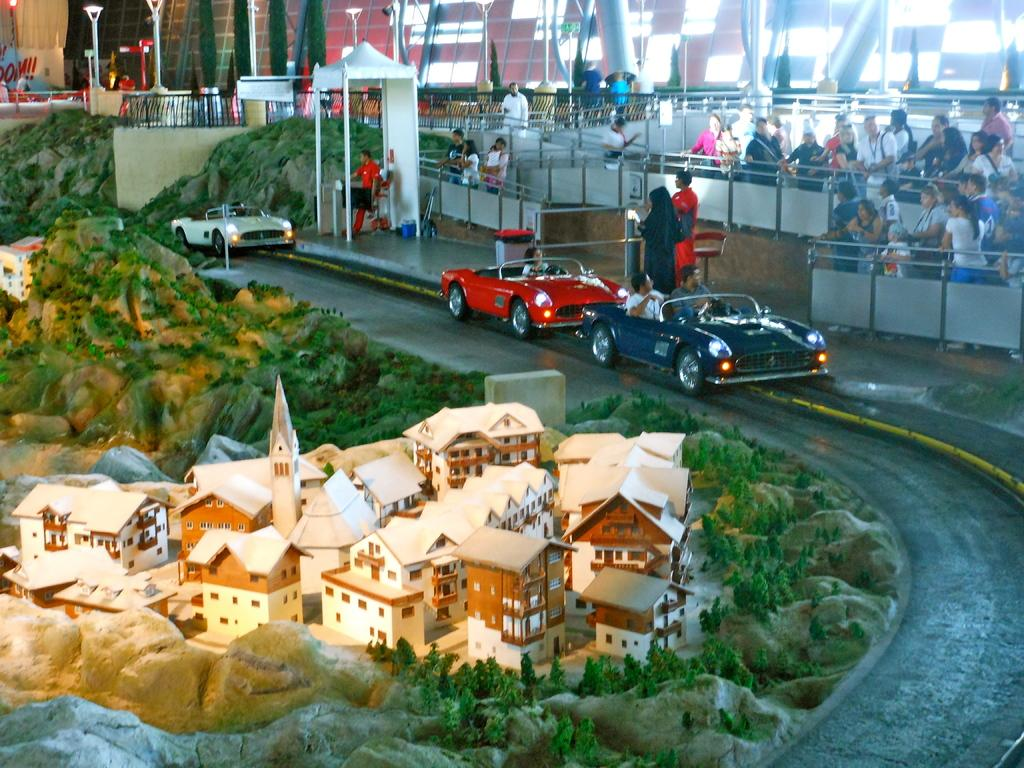What type of structures can be seen in the image? There are houses in the image. What natural elements are present in the image? There are trees in the image. What geological features can be observed in the image? There are rocks in the image. What man-made path is visible in the image? There is a road in the image. What mode of transportation can be seen in the image? There are vehicles in the image. Are there any living beings present in the image? Yes, there are people in the image. What safety feature is present in the image? There are railings in the image. What type of barrier can be seen in the image? There is a wall in the image. What vertical structures are present in the image? There are poles in the image. What flat, rectangular objects can be seen in the image? There are boards in the image. Can you describe any other objects present in the image? There are other objects in the image, but their specific details are not mentioned in the provided facts. What knowledge is being shared at the event in the image? There is no event present in the image, and therefore no knowledge-sharing can be observed. What type of place is depicted in the image? The image does not depict a specific type of place; it contains various elements such as houses, trees, rocks, and roads. 